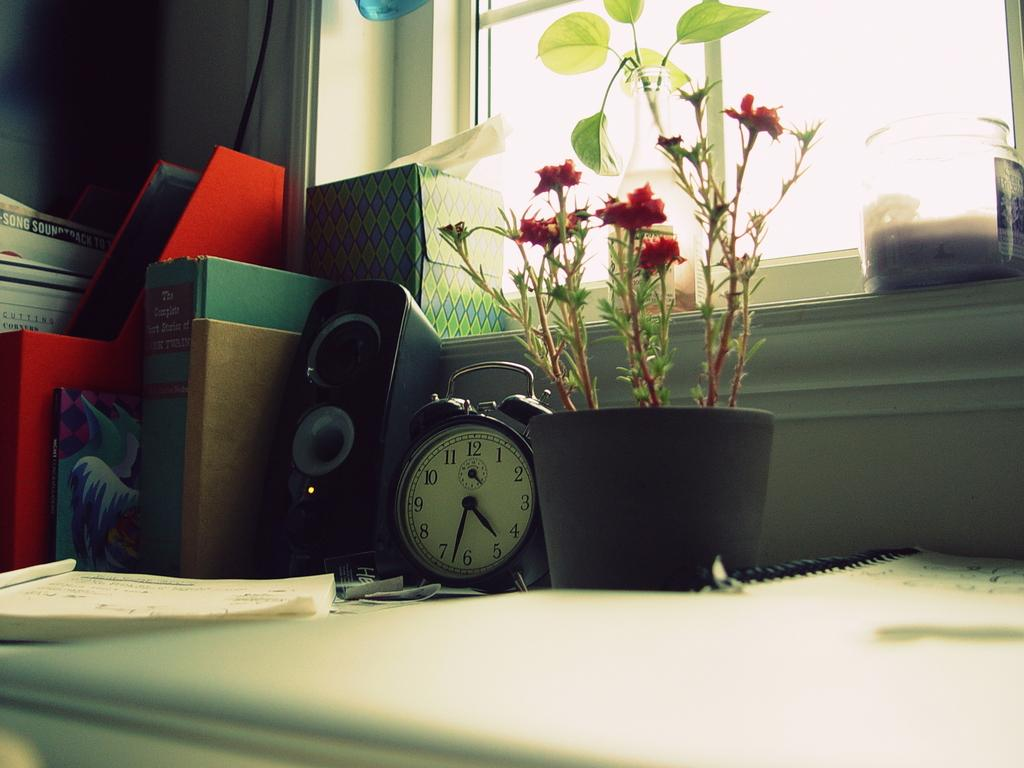<image>
Relay a brief, clear account of the picture shown. A clock by a plant shows a time of a bout 4:32. 